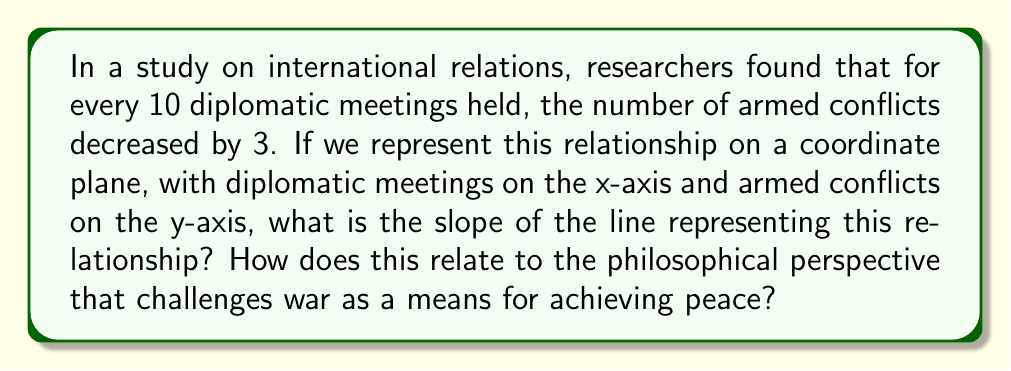Help me with this question. To find the slope of the line, we need to use the slope formula:

$$ m = \frac{\Delta y}{\Delta x} = \frac{y_2 - y_1}{x_2 - x_1} $$

Where:
$m$ is the slope
$\Delta y$ is the change in y (armed conflicts)
$\Delta x$ is the change in x (diplomatic meetings)

From the given information:
$\Delta x = 10$ (diplomatic meetings)
$\Delta y = -3$ (decrease in armed conflicts)

Plugging these values into the slope formula:

$$ m = \frac{-3}{10} = -0.3 $$

The negative slope indicates an inverse relationship between diplomatic efforts and armed conflicts. This aligns with the philosophical perspective challenging war as a means for peace, as it shows that increased diplomatic efforts correlate with decreased conflicts.

To express this as a fraction in lowest terms:

$$ m = -\frac{3}{10} = -\frac{3 \div 3}{10 \div 3} = -\frac{1}{3\frac{1}{3}} $$
Answer: $-\frac{3}{10}$ or $-0.3$ 